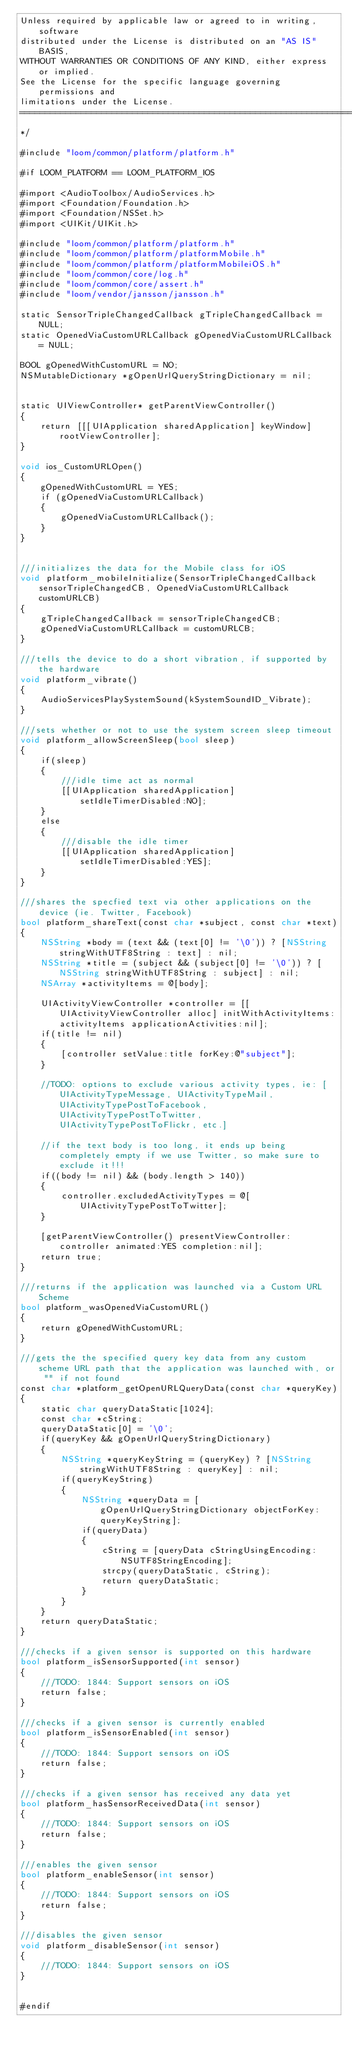<code> <loc_0><loc_0><loc_500><loc_500><_ObjectiveC_>Unless required by applicable law or agreed to in writing, software
distributed under the License is distributed on an "AS IS" BASIS,
WITHOUT WARRANTIES OR CONDITIONS OF ANY KIND, either express or implied.
See the License for the specific language governing permissions and
limitations under the License. 
===========================================================================
*/

#include "loom/common/platform/platform.h"

#if LOOM_PLATFORM == LOOM_PLATFORM_IOS

#import <AudioToolbox/AudioServices.h>
#import <Foundation/Foundation.h>
#import <Foundation/NSSet.h>
#import <UIKit/UIKit.h>

#include "loom/common/platform/platform.h"
#include "loom/common/platform/platformMobile.h"
#include "loom/common/platform/platformMobileiOS.h"
#include "loom/common/core/log.h"
#include "loom/common/core/assert.h"
#include "loom/vendor/jansson/jansson.h"

static SensorTripleChangedCallback gTripleChangedCallback = NULL;
static OpenedViaCustomURLCallback gOpenedViaCustomURLCallback = NULL;

BOOL gOpenedWithCustomURL = NO;
NSMutableDictionary *gOpenUrlQueryStringDictionary = nil;


static UIViewController* getParentViewController()
{
    return [[[UIApplication sharedApplication] keyWindow] rootViewController];
}

void ios_CustomURLOpen()
{
    gOpenedWithCustomURL = YES;
    if (gOpenedViaCustomURLCallback)
    {
        gOpenedViaCustomURLCallback();
    }
}


///initializes the data for the Mobile class for iOS
void platform_mobileInitialize(SensorTripleChangedCallback sensorTripleChangedCB, OpenedViaCustomURLCallback customURLCB)
{
    gTripleChangedCallback = sensorTripleChangedCB;    
    gOpenedViaCustomURLCallback = customURLCB;    
}

///tells the device to do a short vibration, if supported by the hardware
void platform_vibrate()
{
    AudioServicesPlaySystemSound(kSystemSoundID_Vibrate);
}

///sets whether or not to use the system screen sleep timeout
void platform_allowScreenSleep(bool sleep)
{
    if(sleep)
    {
        ///idle time act as normal
        [[UIApplication sharedApplication] setIdleTimerDisabled:NO];
    }
    else
    {
        ///disable the idle timer
        [[UIApplication sharedApplication] setIdleTimerDisabled:YES];
    }
}

///shares the specfied text via other applications on the device (ie. Twitter, Facebook)
bool platform_shareText(const char *subject, const char *text)
{
    NSString *body = (text && (text[0] != '\0')) ? [NSString stringWithUTF8String : text] : nil;
    NSString *title = (subject && (subject[0] != '\0')) ? [NSString stringWithUTF8String : subject] : nil;
    NSArray *activityItems = @[body];

    UIActivityViewController *controller = [[UIActivityViewController alloc] initWithActivityItems:activityItems applicationActivities:nil];
    if(title != nil)
    {
        [controller setValue:title forKey:@"subject"];
    }

    //TODO: options to exclude various activity types, ie: [UIActivityTypeMessage, UIActivityTypeMail, UIActivityTypePostToFacebook, UIActivityTypePostToTwitter, UIActivityTypePostToFlickr, etc.]

    //if the text body is too long, it ends up being completely empty if we use Twitter, so make sure to exclude it!!!
    if((body != nil) && (body.length > 140))
    {
        controller.excludedActivityTypes = @[UIActivityTypePostToTwitter];
    }

    [getParentViewController() presentViewController:controller animated:YES completion:nil];
    return true;
}

///returns if the application was launched via a Custom URL Scheme
bool platform_wasOpenedViaCustomURL()
{
    return gOpenedWithCustomURL;
}

///gets the the specified query key data from any custom scheme URL path that the application was launched with, or "" if not found
const char *platform_getOpenURLQueryData(const char *queryKey)
{
    static char queryDataStatic[1024];
    const char *cString;
    queryDataStatic[0] = '\0';
    if(queryKey && gOpenUrlQueryStringDictionary)
    {
        NSString *queryKeyString = (queryKey) ? [NSString stringWithUTF8String : queryKey] : nil;
        if(queryKeyString)
        {
            NSString *queryData = [gOpenUrlQueryStringDictionary objectForKey:queryKeyString];
            if(queryData)
            {
                cString = [queryData cStringUsingEncoding:NSUTF8StringEncoding];    
                strcpy(queryDataStatic, cString);
                return queryDataStatic;
            }
        }
    }
    return queryDataStatic;
}

///checks if a given sensor is supported on this hardware
bool platform_isSensorSupported(int sensor)
{
    ///TODO: 1844: Support sensors on iOS
    return false;
}

///checks if a given sensor is currently enabled
bool platform_isSensorEnabled(int sensor)
{
    ///TODO: 1844: Support sensors on iOS
    return false;
}

///checks if a given sensor has received any data yet
bool platform_hasSensorReceivedData(int sensor)
{
    ///TODO: 1844: Support sensors on iOS
    return false;
}

///enables the given sensor
bool platform_enableSensor(int sensor)
{
    ///TODO: 1844: Support sensors on iOS
    return false;
}

///disables the given sensor
void platform_disableSensor(int sensor)
{
    ///TODO: 1844: Support sensors on iOS
}


#endif
</code> 